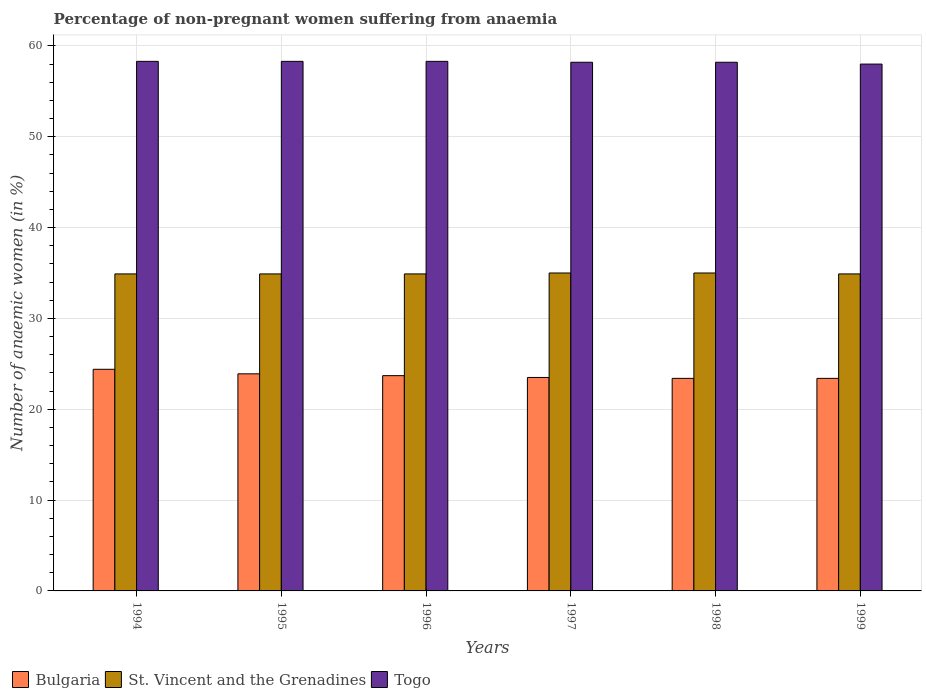Are the number of bars per tick equal to the number of legend labels?
Your answer should be very brief. Yes. Are the number of bars on each tick of the X-axis equal?
Ensure brevity in your answer.  Yes. How many bars are there on the 2nd tick from the left?
Your response must be concise. 3. How many bars are there on the 5th tick from the right?
Keep it short and to the point. 3. What is the label of the 4th group of bars from the left?
Your answer should be very brief. 1997. In how many cases, is the number of bars for a given year not equal to the number of legend labels?
Provide a succinct answer. 0. Across all years, what is the maximum percentage of non-pregnant women suffering from anaemia in Bulgaria?
Make the answer very short. 24.4. In which year was the percentage of non-pregnant women suffering from anaemia in St. Vincent and the Grenadines maximum?
Offer a very short reply. 1997. What is the total percentage of non-pregnant women suffering from anaemia in St. Vincent and the Grenadines in the graph?
Ensure brevity in your answer.  209.6. What is the difference between the percentage of non-pregnant women suffering from anaemia in St. Vincent and the Grenadines in 1998 and the percentage of non-pregnant women suffering from anaemia in Bulgaria in 1997?
Offer a terse response. 11.5. What is the average percentage of non-pregnant women suffering from anaemia in Togo per year?
Make the answer very short. 58.22. In the year 1994, what is the difference between the percentage of non-pregnant women suffering from anaemia in St. Vincent and the Grenadines and percentage of non-pregnant women suffering from anaemia in Togo?
Provide a short and direct response. -23.4. What does the 2nd bar from the left in 1994 represents?
Your response must be concise. St. Vincent and the Grenadines. What does the 1st bar from the right in 1996 represents?
Keep it short and to the point. Togo. How many bars are there?
Offer a terse response. 18. How many years are there in the graph?
Offer a very short reply. 6. What is the difference between two consecutive major ticks on the Y-axis?
Your response must be concise. 10. Does the graph contain grids?
Offer a very short reply. Yes. How many legend labels are there?
Ensure brevity in your answer.  3. How are the legend labels stacked?
Make the answer very short. Horizontal. What is the title of the graph?
Provide a short and direct response. Percentage of non-pregnant women suffering from anaemia. Does "Ecuador" appear as one of the legend labels in the graph?
Make the answer very short. No. What is the label or title of the Y-axis?
Your answer should be very brief. Number of anaemic women (in %). What is the Number of anaemic women (in %) in Bulgaria in 1994?
Keep it short and to the point. 24.4. What is the Number of anaemic women (in %) in St. Vincent and the Grenadines in 1994?
Your answer should be compact. 34.9. What is the Number of anaemic women (in %) in Togo in 1994?
Give a very brief answer. 58.3. What is the Number of anaemic women (in %) in Bulgaria in 1995?
Keep it short and to the point. 23.9. What is the Number of anaemic women (in %) of St. Vincent and the Grenadines in 1995?
Your response must be concise. 34.9. What is the Number of anaemic women (in %) in Togo in 1995?
Offer a terse response. 58.3. What is the Number of anaemic women (in %) of Bulgaria in 1996?
Make the answer very short. 23.7. What is the Number of anaemic women (in %) of St. Vincent and the Grenadines in 1996?
Ensure brevity in your answer.  34.9. What is the Number of anaemic women (in %) in Togo in 1996?
Provide a short and direct response. 58.3. What is the Number of anaemic women (in %) in Bulgaria in 1997?
Your answer should be very brief. 23.5. What is the Number of anaemic women (in %) in St. Vincent and the Grenadines in 1997?
Your answer should be compact. 35. What is the Number of anaemic women (in %) in Togo in 1997?
Your response must be concise. 58.2. What is the Number of anaemic women (in %) of Bulgaria in 1998?
Provide a short and direct response. 23.4. What is the Number of anaemic women (in %) of Togo in 1998?
Your answer should be very brief. 58.2. What is the Number of anaemic women (in %) of Bulgaria in 1999?
Provide a short and direct response. 23.4. What is the Number of anaemic women (in %) of St. Vincent and the Grenadines in 1999?
Offer a terse response. 34.9. Across all years, what is the maximum Number of anaemic women (in %) of Bulgaria?
Provide a succinct answer. 24.4. Across all years, what is the maximum Number of anaemic women (in %) in Togo?
Provide a short and direct response. 58.3. Across all years, what is the minimum Number of anaemic women (in %) of Bulgaria?
Give a very brief answer. 23.4. Across all years, what is the minimum Number of anaemic women (in %) of St. Vincent and the Grenadines?
Make the answer very short. 34.9. What is the total Number of anaemic women (in %) in Bulgaria in the graph?
Make the answer very short. 142.3. What is the total Number of anaemic women (in %) in St. Vincent and the Grenadines in the graph?
Your answer should be very brief. 209.6. What is the total Number of anaemic women (in %) in Togo in the graph?
Provide a succinct answer. 349.3. What is the difference between the Number of anaemic women (in %) of Bulgaria in 1994 and that in 1995?
Keep it short and to the point. 0.5. What is the difference between the Number of anaemic women (in %) in St. Vincent and the Grenadines in 1994 and that in 1995?
Offer a terse response. 0. What is the difference between the Number of anaemic women (in %) of Togo in 1994 and that in 1995?
Offer a very short reply. 0. What is the difference between the Number of anaemic women (in %) in Bulgaria in 1994 and that in 1997?
Offer a terse response. 0.9. What is the difference between the Number of anaemic women (in %) in St. Vincent and the Grenadines in 1994 and that in 1997?
Offer a very short reply. -0.1. What is the difference between the Number of anaemic women (in %) of Bulgaria in 1994 and that in 1998?
Your answer should be very brief. 1. What is the difference between the Number of anaemic women (in %) of St. Vincent and the Grenadines in 1994 and that in 1998?
Keep it short and to the point. -0.1. What is the difference between the Number of anaemic women (in %) of Togo in 1994 and that in 1998?
Offer a very short reply. 0.1. What is the difference between the Number of anaemic women (in %) in St. Vincent and the Grenadines in 1994 and that in 1999?
Make the answer very short. 0. What is the difference between the Number of anaemic women (in %) in Bulgaria in 1995 and that in 1996?
Make the answer very short. 0.2. What is the difference between the Number of anaemic women (in %) in St. Vincent and the Grenadines in 1995 and that in 1996?
Offer a terse response. 0. What is the difference between the Number of anaemic women (in %) of Togo in 1995 and that in 1996?
Provide a succinct answer. 0. What is the difference between the Number of anaemic women (in %) in Bulgaria in 1995 and that in 1997?
Your answer should be compact. 0.4. What is the difference between the Number of anaemic women (in %) in Bulgaria in 1995 and that in 1998?
Offer a terse response. 0.5. What is the difference between the Number of anaemic women (in %) in St. Vincent and the Grenadines in 1995 and that in 1998?
Keep it short and to the point. -0.1. What is the difference between the Number of anaemic women (in %) in St. Vincent and the Grenadines in 1996 and that in 1998?
Give a very brief answer. -0.1. What is the difference between the Number of anaemic women (in %) in Togo in 1996 and that in 1998?
Your response must be concise. 0.1. What is the difference between the Number of anaemic women (in %) in Bulgaria in 1996 and that in 1999?
Provide a short and direct response. 0.3. What is the difference between the Number of anaemic women (in %) in St. Vincent and the Grenadines in 1996 and that in 1999?
Your answer should be compact. 0. What is the difference between the Number of anaemic women (in %) in Togo in 1996 and that in 1999?
Provide a short and direct response. 0.3. What is the difference between the Number of anaemic women (in %) of Togo in 1997 and that in 1998?
Provide a succinct answer. 0. What is the difference between the Number of anaemic women (in %) in St. Vincent and the Grenadines in 1997 and that in 1999?
Make the answer very short. 0.1. What is the difference between the Number of anaemic women (in %) of Bulgaria in 1998 and that in 1999?
Give a very brief answer. 0. What is the difference between the Number of anaemic women (in %) in Bulgaria in 1994 and the Number of anaemic women (in %) in Togo in 1995?
Make the answer very short. -33.9. What is the difference between the Number of anaemic women (in %) of St. Vincent and the Grenadines in 1994 and the Number of anaemic women (in %) of Togo in 1995?
Your response must be concise. -23.4. What is the difference between the Number of anaemic women (in %) in Bulgaria in 1994 and the Number of anaemic women (in %) in St. Vincent and the Grenadines in 1996?
Offer a very short reply. -10.5. What is the difference between the Number of anaemic women (in %) of Bulgaria in 1994 and the Number of anaemic women (in %) of Togo in 1996?
Your answer should be very brief. -33.9. What is the difference between the Number of anaemic women (in %) of St. Vincent and the Grenadines in 1994 and the Number of anaemic women (in %) of Togo in 1996?
Offer a very short reply. -23.4. What is the difference between the Number of anaemic women (in %) of Bulgaria in 1994 and the Number of anaemic women (in %) of Togo in 1997?
Provide a succinct answer. -33.8. What is the difference between the Number of anaemic women (in %) in St. Vincent and the Grenadines in 1994 and the Number of anaemic women (in %) in Togo in 1997?
Your answer should be compact. -23.3. What is the difference between the Number of anaemic women (in %) in Bulgaria in 1994 and the Number of anaemic women (in %) in St. Vincent and the Grenadines in 1998?
Your answer should be compact. -10.6. What is the difference between the Number of anaemic women (in %) of Bulgaria in 1994 and the Number of anaemic women (in %) of Togo in 1998?
Your response must be concise. -33.8. What is the difference between the Number of anaemic women (in %) in St. Vincent and the Grenadines in 1994 and the Number of anaemic women (in %) in Togo in 1998?
Your answer should be very brief. -23.3. What is the difference between the Number of anaemic women (in %) in Bulgaria in 1994 and the Number of anaemic women (in %) in Togo in 1999?
Keep it short and to the point. -33.6. What is the difference between the Number of anaemic women (in %) of St. Vincent and the Grenadines in 1994 and the Number of anaemic women (in %) of Togo in 1999?
Keep it short and to the point. -23.1. What is the difference between the Number of anaemic women (in %) in Bulgaria in 1995 and the Number of anaemic women (in %) in Togo in 1996?
Your answer should be very brief. -34.4. What is the difference between the Number of anaemic women (in %) in St. Vincent and the Grenadines in 1995 and the Number of anaemic women (in %) in Togo in 1996?
Provide a short and direct response. -23.4. What is the difference between the Number of anaemic women (in %) in Bulgaria in 1995 and the Number of anaemic women (in %) in St. Vincent and the Grenadines in 1997?
Offer a very short reply. -11.1. What is the difference between the Number of anaemic women (in %) of Bulgaria in 1995 and the Number of anaemic women (in %) of Togo in 1997?
Ensure brevity in your answer.  -34.3. What is the difference between the Number of anaemic women (in %) of St. Vincent and the Grenadines in 1995 and the Number of anaemic women (in %) of Togo in 1997?
Your answer should be compact. -23.3. What is the difference between the Number of anaemic women (in %) in Bulgaria in 1995 and the Number of anaemic women (in %) in Togo in 1998?
Provide a short and direct response. -34.3. What is the difference between the Number of anaemic women (in %) in St. Vincent and the Grenadines in 1995 and the Number of anaemic women (in %) in Togo in 1998?
Your answer should be compact. -23.3. What is the difference between the Number of anaemic women (in %) in Bulgaria in 1995 and the Number of anaemic women (in %) in Togo in 1999?
Your answer should be very brief. -34.1. What is the difference between the Number of anaemic women (in %) in St. Vincent and the Grenadines in 1995 and the Number of anaemic women (in %) in Togo in 1999?
Make the answer very short. -23.1. What is the difference between the Number of anaemic women (in %) in Bulgaria in 1996 and the Number of anaemic women (in %) in St. Vincent and the Grenadines in 1997?
Make the answer very short. -11.3. What is the difference between the Number of anaemic women (in %) of Bulgaria in 1996 and the Number of anaemic women (in %) of Togo in 1997?
Make the answer very short. -34.5. What is the difference between the Number of anaemic women (in %) of St. Vincent and the Grenadines in 1996 and the Number of anaemic women (in %) of Togo in 1997?
Provide a succinct answer. -23.3. What is the difference between the Number of anaemic women (in %) in Bulgaria in 1996 and the Number of anaemic women (in %) in St. Vincent and the Grenadines in 1998?
Your answer should be compact. -11.3. What is the difference between the Number of anaemic women (in %) of Bulgaria in 1996 and the Number of anaemic women (in %) of Togo in 1998?
Offer a very short reply. -34.5. What is the difference between the Number of anaemic women (in %) of St. Vincent and the Grenadines in 1996 and the Number of anaemic women (in %) of Togo in 1998?
Make the answer very short. -23.3. What is the difference between the Number of anaemic women (in %) in Bulgaria in 1996 and the Number of anaemic women (in %) in Togo in 1999?
Offer a terse response. -34.3. What is the difference between the Number of anaemic women (in %) of St. Vincent and the Grenadines in 1996 and the Number of anaemic women (in %) of Togo in 1999?
Make the answer very short. -23.1. What is the difference between the Number of anaemic women (in %) in Bulgaria in 1997 and the Number of anaemic women (in %) in St. Vincent and the Grenadines in 1998?
Offer a terse response. -11.5. What is the difference between the Number of anaemic women (in %) in Bulgaria in 1997 and the Number of anaemic women (in %) in Togo in 1998?
Offer a very short reply. -34.7. What is the difference between the Number of anaemic women (in %) of St. Vincent and the Grenadines in 1997 and the Number of anaemic women (in %) of Togo in 1998?
Your answer should be compact. -23.2. What is the difference between the Number of anaemic women (in %) of Bulgaria in 1997 and the Number of anaemic women (in %) of St. Vincent and the Grenadines in 1999?
Offer a very short reply. -11.4. What is the difference between the Number of anaemic women (in %) in Bulgaria in 1997 and the Number of anaemic women (in %) in Togo in 1999?
Provide a short and direct response. -34.5. What is the difference between the Number of anaemic women (in %) in Bulgaria in 1998 and the Number of anaemic women (in %) in St. Vincent and the Grenadines in 1999?
Offer a terse response. -11.5. What is the difference between the Number of anaemic women (in %) of Bulgaria in 1998 and the Number of anaemic women (in %) of Togo in 1999?
Provide a short and direct response. -34.6. What is the average Number of anaemic women (in %) in Bulgaria per year?
Give a very brief answer. 23.72. What is the average Number of anaemic women (in %) of St. Vincent and the Grenadines per year?
Your response must be concise. 34.93. What is the average Number of anaemic women (in %) of Togo per year?
Give a very brief answer. 58.22. In the year 1994, what is the difference between the Number of anaemic women (in %) of Bulgaria and Number of anaemic women (in %) of St. Vincent and the Grenadines?
Provide a succinct answer. -10.5. In the year 1994, what is the difference between the Number of anaemic women (in %) of Bulgaria and Number of anaemic women (in %) of Togo?
Your answer should be compact. -33.9. In the year 1994, what is the difference between the Number of anaemic women (in %) of St. Vincent and the Grenadines and Number of anaemic women (in %) of Togo?
Provide a succinct answer. -23.4. In the year 1995, what is the difference between the Number of anaemic women (in %) of Bulgaria and Number of anaemic women (in %) of St. Vincent and the Grenadines?
Keep it short and to the point. -11. In the year 1995, what is the difference between the Number of anaemic women (in %) in Bulgaria and Number of anaemic women (in %) in Togo?
Make the answer very short. -34.4. In the year 1995, what is the difference between the Number of anaemic women (in %) in St. Vincent and the Grenadines and Number of anaemic women (in %) in Togo?
Provide a short and direct response. -23.4. In the year 1996, what is the difference between the Number of anaemic women (in %) in Bulgaria and Number of anaemic women (in %) in St. Vincent and the Grenadines?
Make the answer very short. -11.2. In the year 1996, what is the difference between the Number of anaemic women (in %) in Bulgaria and Number of anaemic women (in %) in Togo?
Your answer should be very brief. -34.6. In the year 1996, what is the difference between the Number of anaemic women (in %) in St. Vincent and the Grenadines and Number of anaemic women (in %) in Togo?
Offer a terse response. -23.4. In the year 1997, what is the difference between the Number of anaemic women (in %) in Bulgaria and Number of anaemic women (in %) in St. Vincent and the Grenadines?
Ensure brevity in your answer.  -11.5. In the year 1997, what is the difference between the Number of anaemic women (in %) of Bulgaria and Number of anaemic women (in %) of Togo?
Your response must be concise. -34.7. In the year 1997, what is the difference between the Number of anaemic women (in %) of St. Vincent and the Grenadines and Number of anaemic women (in %) of Togo?
Give a very brief answer. -23.2. In the year 1998, what is the difference between the Number of anaemic women (in %) of Bulgaria and Number of anaemic women (in %) of St. Vincent and the Grenadines?
Offer a very short reply. -11.6. In the year 1998, what is the difference between the Number of anaemic women (in %) of Bulgaria and Number of anaemic women (in %) of Togo?
Your answer should be compact. -34.8. In the year 1998, what is the difference between the Number of anaemic women (in %) of St. Vincent and the Grenadines and Number of anaemic women (in %) of Togo?
Make the answer very short. -23.2. In the year 1999, what is the difference between the Number of anaemic women (in %) in Bulgaria and Number of anaemic women (in %) in St. Vincent and the Grenadines?
Offer a very short reply. -11.5. In the year 1999, what is the difference between the Number of anaemic women (in %) of Bulgaria and Number of anaemic women (in %) of Togo?
Offer a terse response. -34.6. In the year 1999, what is the difference between the Number of anaemic women (in %) in St. Vincent and the Grenadines and Number of anaemic women (in %) in Togo?
Provide a short and direct response. -23.1. What is the ratio of the Number of anaemic women (in %) in Bulgaria in 1994 to that in 1995?
Provide a succinct answer. 1.02. What is the ratio of the Number of anaemic women (in %) of St. Vincent and the Grenadines in 1994 to that in 1995?
Keep it short and to the point. 1. What is the ratio of the Number of anaemic women (in %) in Bulgaria in 1994 to that in 1996?
Provide a short and direct response. 1.03. What is the ratio of the Number of anaemic women (in %) in Togo in 1994 to that in 1996?
Your answer should be compact. 1. What is the ratio of the Number of anaemic women (in %) of Bulgaria in 1994 to that in 1997?
Keep it short and to the point. 1.04. What is the ratio of the Number of anaemic women (in %) in Togo in 1994 to that in 1997?
Your response must be concise. 1. What is the ratio of the Number of anaemic women (in %) of Bulgaria in 1994 to that in 1998?
Make the answer very short. 1.04. What is the ratio of the Number of anaemic women (in %) of Togo in 1994 to that in 1998?
Your answer should be very brief. 1. What is the ratio of the Number of anaemic women (in %) of Bulgaria in 1994 to that in 1999?
Provide a succinct answer. 1.04. What is the ratio of the Number of anaemic women (in %) of St. Vincent and the Grenadines in 1994 to that in 1999?
Offer a very short reply. 1. What is the ratio of the Number of anaemic women (in %) in Bulgaria in 1995 to that in 1996?
Keep it short and to the point. 1.01. What is the ratio of the Number of anaemic women (in %) in St. Vincent and the Grenadines in 1995 to that in 1997?
Offer a very short reply. 1. What is the ratio of the Number of anaemic women (in %) of Togo in 1995 to that in 1997?
Make the answer very short. 1. What is the ratio of the Number of anaemic women (in %) of Bulgaria in 1995 to that in 1998?
Provide a short and direct response. 1.02. What is the ratio of the Number of anaemic women (in %) of St. Vincent and the Grenadines in 1995 to that in 1998?
Your answer should be very brief. 1. What is the ratio of the Number of anaemic women (in %) of Bulgaria in 1995 to that in 1999?
Keep it short and to the point. 1.02. What is the ratio of the Number of anaemic women (in %) in Togo in 1995 to that in 1999?
Offer a very short reply. 1.01. What is the ratio of the Number of anaemic women (in %) of Bulgaria in 1996 to that in 1997?
Offer a very short reply. 1.01. What is the ratio of the Number of anaemic women (in %) of St. Vincent and the Grenadines in 1996 to that in 1997?
Ensure brevity in your answer.  1. What is the ratio of the Number of anaemic women (in %) in Bulgaria in 1996 to that in 1998?
Your answer should be compact. 1.01. What is the ratio of the Number of anaemic women (in %) in St. Vincent and the Grenadines in 1996 to that in 1998?
Provide a short and direct response. 1. What is the ratio of the Number of anaemic women (in %) in Togo in 1996 to that in 1998?
Give a very brief answer. 1. What is the ratio of the Number of anaemic women (in %) in Bulgaria in 1996 to that in 1999?
Your answer should be compact. 1.01. What is the ratio of the Number of anaemic women (in %) in Togo in 1996 to that in 1999?
Give a very brief answer. 1.01. What is the ratio of the Number of anaemic women (in %) of Bulgaria in 1997 to that in 1999?
Offer a very short reply. 1. What is the ratio of the Number of anaemic women (in %) of St. Vincent and the Grenadines in 1997 to that in 1999?
Offer a very short reply. 1. What is the ratio of the Number of anaemic women (in %) in Togo in 1998 to that in 1999?
Offer a terse response. 1. What is the difference between the highest and the second highest Number of anaemic women (in %) in St. Vincent and the Grenadines?
Your answer should be compact. 0. What is the difference between the highest and the lowest Number of anaemic women (in %) in Bulgaria?
Offer a terse response. 1. What is the difference between the highest and the lowest Number of anaemic women (in %) of St. Vincent and the Grenadines?
Your answer should be very brief. 0.1. 